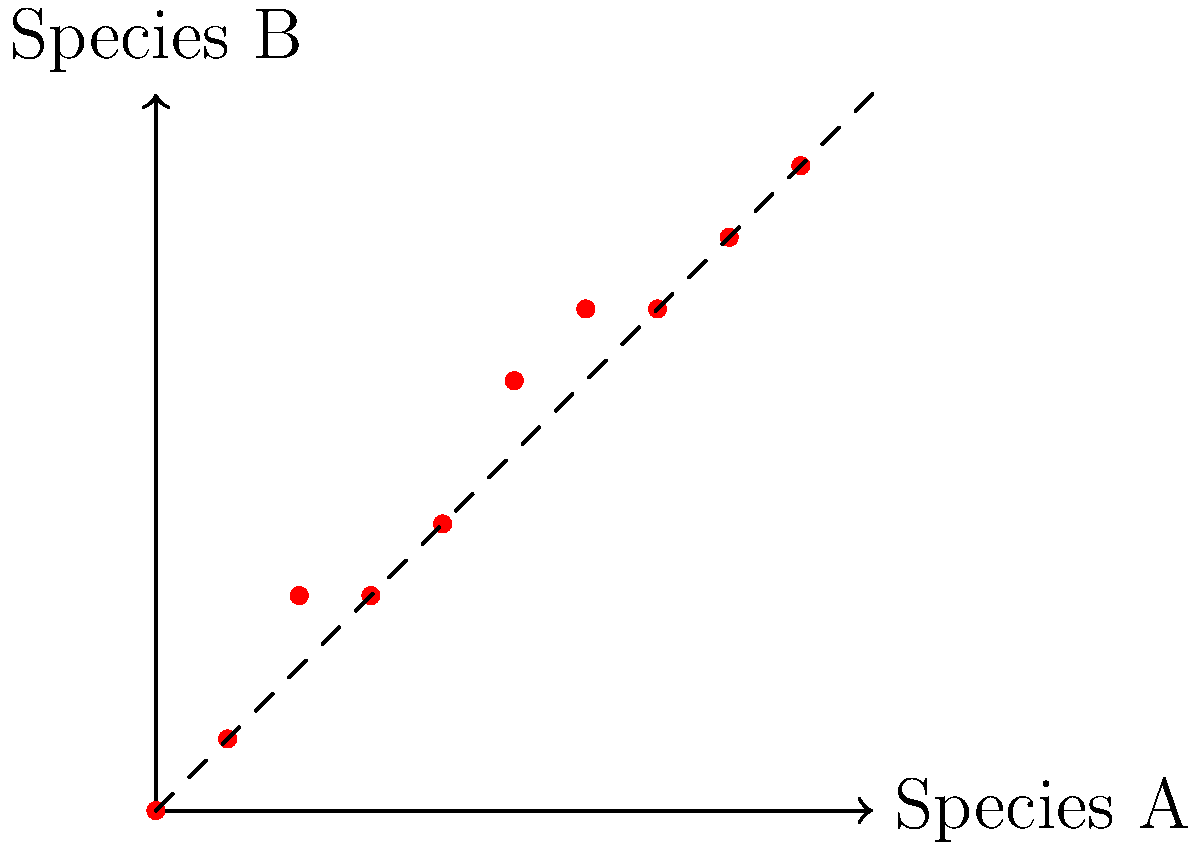Analyze the dotplot visualization comparing genomic sequences of two endangered species (A and B). What can be inferred about their potential adaptive traits based on the pattern observed? To analyze the dotplot and infer potential adaptive traits, we need to follow these steps:

1. Understand the dotplot: Each dot represents a match between sequences of Species A (x-axis) and Species B (y-axis).

2. Observe the overall pattern: The dots roughly follow the diagonal line, indicating general sequence similarity between the species.

3. Analyze deviations:
   a. Points above the diagonal suggest insertions in Species B or deletions in Species A.
   b. Points below the diagonal suggest insertions in Species A or deletions in Species B.

4. Identify regions of interest:
   - The plot shows a consistent pattern up to position 4 on both axes.
   - Between positions 4 and 6, there's a vertical shift in the pattern.
   - After position 6, the pattern resumes its diagonal trend.

5. Interpret biological significance:
   - The consistent regions suggest conserved sequences, possibly essential genes.
   - The shift between positions 4 and 6 indicates a potential insertion in Species B or deletion in Species A.
   - This region might represent an adaptive trait specific to Species B, such as a gene duplication or a novel genetic element.

6. Consider evolutionary implications:
   - The overall similarity suggests a recent common ancestor.
   - The divergence in the middle region could indicate recent adaptive evolution in Species B.

7. Relate to conservation efforts:
   - Understanding these differences can help in identifying unique genetic features that may be crucial for species survival and adaptation.
Answer: Species B likely has an insertion or gene duplication between positions 4-6, potentially representing an adaptive trait. 